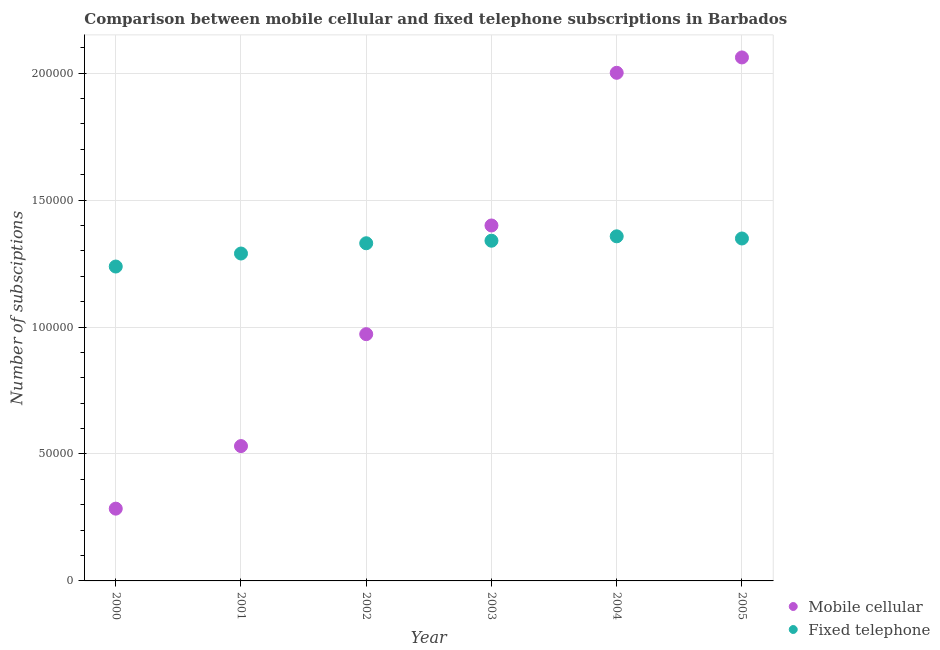Is the number of dotlines equal to the number of legend labels?
Offer a very short reply. Yes. What is the number of mobile cellular subscriptions in 2002?
Your answer should be very brief. 9.72e+04. Across all years, what is the maximum number of mobile cellular subscriptions?
Ensure brevity in your answer.  2.06e+05. Across all years, what is the minimum number of fixed telephone subscriptions?
Offer a very short reply. 1.24e+05. In which year was the number of fixed telephone subscriptions minimum?
Keep it short and to the point. 2000. What is the total number of mobile cellular subscriptions in the graph?
Keep it short and to the point. 7.25e+05. What is the difference between the number of mobile cellular subscriptions in 2004 and that in 2005?
Offer a very short reply. -6052. What is the difference between the number of mobile cellular subscriptions in 2001 and the number of fixed telephone subscriptions in 2000?
Offer a very short reply. -7.07e+04. What is the average number of fixed telephone subscriptions per year?
Offer a terse response. 1.32e+05. In the year 2001, what is the difference between the number of fixed telephone subscriptions and number of mobile cellular subscriptions?
Give a very brief answer. 7.58e+04. In how many years, is the number of fixed telephone subscriptions greater than 130000?
Your response must be concise. 4. What is the ratio of the number of fixed telephone subscriptions in 2002 to that in 2003?
Ensure brevity in your answer.  0.99. Is the number of fixed telephone subscriptions in 2000 less than that in 2001?
Make the answer very short. Yes. What is the difference between the highest and the second highest number of mobile cellular subscriptions?
Keep it short and to the point. 6052. What is the difference between the highest and the lowest number of mobile cellular subscriptions?
Give a very brief answer. 1.78e+05. In how many years, is the number of mobile cellular subscriptions greater than the average number of mobile cellular subscriptions taken over all years?
Your answer should be compact. 3. Does the number of mobile cellular subscriptions monotonically increase over the years?
Offer a terse response. Yes. Is the number of mobile cellular subscriptions strictly greater than the number of fixed telephone subscriptions over the years?
Make the answer very short. No. How many dotlines are there?
Your response must be concise. 2. How many years are there in the graph?
Give a very brief answer. 6. Does the graph contain grids?
Your response must be concise. Yes. How many legend labels are there?
Provide a succinct answer. 2. What is the title of the graph?
Your response must be concise. Comparison between mobile cellular and fixed telephone subscriptions in Barbados. Does "Male labor force" appear as one of the legend labels in the graph?
Your response must be concise. No. What is the label or title of the Y-axis?
Your response must be concise. Number of subsciptions. What is the Number of subsciptions in Mobile cellular in 2000?
Offer a very short reply. 2.85e+04. What is the Number of subsciptions in Fixed telephone in 2000?
Your answer should be compact. 1.24e+05. What is the Number of subsciptions in Mobile cellular in 2001?
Provide a short and direct response. 5.31e+04. What is the Number of subsciptions in Fixed telephone in 2001?
Offer a very short reply. 1.29e+05. What is the Number of subsciptions in Mobile cellular in 2002?
Ensure brevity in your answer.  9.72e+04. What is the Number of subsciptions in Fixed telephone in 2002?
Provide a succinct answer. 1.33e+05. What is the Number of subsciptions in Fixed telephone in 2003?
Your response must be concise. 1.34e+05. What is the Number of subsciptions of Mobile cellular in 2004?
Your response must be concise. 2.00e+05. What is the Number of subsciptions in Fixed telephone in 2004?
Offer a terse response. 1.36e+05. What is the Number of subsciptions in Mobile cellular in 2005?
Your answer should be compact. 2.06e+05. What is the Number of subsciptions in Fixed telephone in 2005?
Ensure brevity in your answer.  1.35e+05. Across all years, what is the maximum Number of subsciptions in Mobile cellular?
Give a very brief answer. 2.06e+05. Across all years, what is the maximum Number of subsciptions in Fixed telephone?
Provide a succinct answer. 1.36e+05. Across all years, what is the minimum Number of subsciptions in Mobile cellular?
Your answer should be compact. 2.85e+04. Across all years, what is the minimum Number of subsciptions of Fixed telephone?
Offer a terse response. 1.24e+05. What is the total Number of subsciptions of Mobile cellular in the graph?
Offer a very short reply. 7.25e+05. What is the total Number of subsciptions of Fixed telephone in the graph?
Ensure brevity in your answer.  7.90e+05. What is the difference between the Number of subsciptions of Mobile cellular in 2000 and that in 2001?
Your response must be concise. -2.46e+04. What is the difference between the Number of subsciptions of Fixed telephone in 2000 and that in 2001?
Ensure brevity in your answer.  -5124. What is the difference between the Number of subsciptions of Mobile cellular in 2000 and that in 2002?
Offer a very short reply. -6.87e+04. What is the difference between the Number of subsciptions of Fixed telephone in 2000 and that in 2002?
Provide a succinct answer. -9168. What is the difference between the Number of subsciptions in Mobile cellular in 2000 and that in 2003?
Offer a terse response. -1.12e+05. What is the difference between the Number of subsciptions of Fixed telephone in 2000 and that in 2003?
Your response must be concise. -1.02e+04. What is the difference between the Number of subsciptions of Mobile cellular in 2000 and that in 2004?
Give a very brief answer. -1.72e+05. What is the difference between the Number of subsciptions of Fixed telephone in 2000 and that in 2004?
Your answer should be compact. -1.19e+04. What is the difference between the Number of subsciptions in Mobile cellular in 2000 and that in 2005?
Your answer should be compact. -1.78e+05. What is the difference between the Number of subsciptions of Fixed telephone in 2000 and that in 2005?
Give a very brief answer. -1.10e+04. What is the difference between the Number of subsciptions of Mobile cellular in 2001 and that in 2002?
Your response must be concise. -4.41e+04. What is the difference between the Number of subsciptions of Fixed telephone in 2001 and that in 2002?
Offer a very short reply. -4044. What is the difference between the Number of subsciptions of Mobile cellular in 2001 and that in 2003?
Offer a very short reply. -8.69e+04. What is the difference between the Number of subsciptions of Fixed telephone in 2001 and that in 2003?
Offer a very short reply. -5044. What is the difference between the Number of subsciptions of Mobile cellular in 2001 and that in 2004?
Offer a very short reply. -1.47e+05. What is the difference between the Number of subsciptions of Fixed telephone in 2001 and that in 2004?
Give a very brief answer. -6776. What is the difference between the Number of subsciptions in Mobile cellular in 2001 and that in 2005?
Your answer should be compact. -1.53e+05. What is the difference between the Number of subsciptions in Fixed telephone in 2001 and that in 2005?
Your answer should be compact. -5922. What is the difference between the Number of subsciptions in Mobile cellular in 2002 and that in 2003?
Your answer should be compact. -4.28e+04. What is the difference between the Number of subsciptions in Fixed telephone in 2002 and that in 2003?
Keep it short and to the point. -1000. What is the difference between the Number of subsciptions of Mobile cellular in 2002 and that in 2004?
Provide a succinct answer. -1.03e+05. What is the difference between the Number of subsciptions in Fixed telephone in 2002 and that in 2004?
Ensure brevity in your answer.  -2732. What is the difference between the Number of subsciptions in Mobile cellular in 2002 and that in 2005?
Your answer should be very brief. -1.09e+05. What is the difference between the Number of subsciptions in Fixed telephone in 2002 and that in 2005?
Offer a very short reply. -1878. What is the difference between the Number of subsciptions in Mobile cellular in 2003 and that in 2004?
Your answer should be very brief. -6.01e+04. What is the difference between the Number of subsciptions of Fixed telephone in 2003 and that in 2004?
Your response must be concise. -1732. What is the difference between the Number of subsciptions in Mobile cellular in 2003 and that in 2005?
Keep it short and to the point. -6.62e+04. What is the difference between the Number of subsciptions in Fixed telephone in 2003 and that in 2005?
Ensure brevity in your answer.  -878. What is the difference between the Number of subsciptions in Mobile cellular in 2004 and that in 2005?
Your answer should be very brief. -6052. What is the difference between the Number of subsciptions of Fixed telephone in 2004 and that in 2005?
Provide a short and direct response. 854. What is the difference between the Number of subsciptions in Mobile cellular in 2000 and the Number of subsciptions in Fixed telephone in 2001?
Your answer should be very brief. -1.00e+05. What is the difference between the Number of subsciptions in Mobile cellular in 2000 and the Number of subsciptions in Fixed telephone in 2002?
Provide a short and direct response. -1.05e+05. What is the difference between the Number of subsciptions in Mobile cellular in 2000 and the Number of subsciptions in Fixed telephone in 2003?
Your response must be concise. -1.06e+05. What is the difference between the Number of subsciptions of Mobile cellular in 2000 and the Number of subsciptions of Fixed telephone in 2004?
Provide a succinct answer. -1.07e+05. What is the difference between the Number of subsciptions of Mobile cellular in 2000 and the Number of subsciptions of Fixed telephone in 2005?
Your response must be concise. -1.06e+05. What is the difference between the Number of subsciptions of Mobile cellular in 2001 and the Number of subsciptions of Fixed telephone in 2002?
Your answer should be very brief. -7.99e+04. What is the difference between the Number of subsciptions in Mobile cellular in 2001 and the Number of subsciptions in Fixed telephone in 2003?
Offer a terse response. -8.09e+04. What is the difference between the Number of subsciptions of Mobile cellular in 2001 and the Number of subsciptions of Fixed telephone in 2004?
Your answer should be very brief. -8.26e+04. What is the difference between the Number of subsciptions of Mobile cellular in 2001 and the Number of subsciptions of Fixed telephone in 2005?
Keep it short and to the point. -8.18e+04. What is the difference between the Number of subsciptions of Mobile cellular in 2002 and the Number of subsciptions of Fixed telephone in 2003?
Your response must be concise. -3.68e+04. What is the difference between the Number of subsciptions in Mobile cellular in 2002 and the Number of subsciptions in Fixed telephone in 2004?
Offer a very short reply. -3.85e+04. What is the difference between the Number of subsciptions in Mobile cellular in 2002 and the Number of subsciptions in Fixed telephone in 2005?
Your answer should be compact. -3.77e+04. What is the difference between the Number of subsciptions of Mobile cellular in 2003 and the Number of subsciptions of Fixed telephone in 2004?
Provide a succinct answer. 4268. What is the difference between the Number of subsciptions of Mobile cellular in 2003 and the Number of subsciptions of Fixed telephone in 2005?
Give a very brief answer. 5122. What is the difference between the Number of subsciptions of Mobile cellular in 2004 and the Number of subsciptions of Fixed telephone in 2005?
Offer a terse response. 6.53e+04. What is the average Number of subsciptions in Mobile cellular per year?
Keep it short and to the point. 1.21e+05. What is the average Number of subsciptions of Fixed telephone per year?
Make the answer very short. 1.32e+05. In the year 2000, what is the difference between the Number of subsciptions in Mobile cellular and Number of subsciptions in Fixed telephone?
Keep it short and to the point. -9.54e+04. In the year 2001, what is the difference between the Number of subsciptions in Mobile cellular and Number of subsciptions in Fixed telephone?
Your answer should be compact. -7.58e+04. In the year 2002, what is the difference between the Number of subsciptions in Mobile cellular and Number of subsciptions in Fixed telephone?
Provide a succinct answer. -3.58e+04. In the year 2003, what is the difference between the Number of subsciptions of Mobile cellular and Number of subsciptions of Fixed telephone?
Keep it short and to the point. 6000. In the year 2004, what is the difference between the Number of subsciptions in Mobile cellular and Number of subsciptions in Fixed telephone?
Your answer should be compact. 6.44e+04. In the year 2005, what is the difference between the Number of subsciptions of Mobile cellular and Number of subsciptions of Fixed telephone?
Provide a succinct answer. 7.13e+04. What is the ratio of the Number of subsciptions of Mobile cellular in 2000 to that in 2001?
Your answer should be compact. 0.54. What is the ratio of the Number of subsciptions of Fixed telephone in 2000 to that in 2001?
Ensure brevity in your answer.  0.96. What is the ratio of the Number of subsciptions in Mobile cellular in 2000 to that in 2002?
Ensure brevity in your answer.  0.29. What is the ratio of the Number of subsciptions in Fixed telephone in 2000 to that in 2002?
Offer a terse response. 0.93. What is the ratio of the Number of subsciptions in Mobile cellular in 2000 to that in 2003?
Ensure brevity in your answer.  0.2. What is the ratio of the Number of subsciptions in Fixed telephone in 2000 to that in 2003?
Provide a succinct answer. 0.92. What is the ratio of the Number of subsciptions in Mobile cellular in 2000 to that in 2004?
Your answer should be compact. 0.14. What is the ratio of the Number of subsciptions of Fixed telephone in 2000 to that in 2004?
Ensure brevity in your answer.  0.91. What is the ratio of the Number of subsciptions in Mobile cellular in 2000 to that in 2005?
Offer a very short reply. 0.14. What is the ratio of the Number of subsciptions in Fixed telephone in 2000 to that in 2005?
Provide a short and direct response. 0.92. What is the ratio of the Number of subsciptions of Mobile cellular in 2001 to that in 2002?
Provide a succinct answer. 0.55. What is the ratio of the Number of subsciptions in Fixed telephone in 2001 to that in 2002?
Offer a very short reply. 0.97. What is the ratio of the Number of subsciptions in Mobile cellular in 2001 to that in 2003?
Your answer should be very brief. 0.38. What is the ratio of the Number of subsciptions in Fixed telephone in 2001 to that in 2003?
Provide a succinct answer. 0.96. What is the ratio of the Number of subsciptions of Mobile cellular in 2001 to that in 2004?
Ensure brevity in your answer.  0.27. What is the ratio of the Number of subsciptions in Fixed telephone in 2001 to that in 2004?
Your answer should be compact. 0.95. What is the ratio of the Number of subsciptions of Mobile cellular in 2001 to that in 2005?
Give a very brief answer. 0.26. What is the ratio of the Number of subsciptions in Fixed telephone in 2001 to that in 2005?
Your answer should be compact. 0.96. What is the ratio of the Number of subsciptions of Mobile cellular in 2002 to that in 2003?
Make the answer very short. 0.69. What is the ratio of the Number of subsciptions of Fixed telephone in 2002 to that in 2003?
Offer a terse response. 0.99. What is the ratio of the Number of subsciptions of Mobile cellular in 2002 to that in 2004?
Provide a short and direct response. 0.49. What is the ratio of the Number of subsciptions in Fixed telephone in 2002 to that in 2004?
Ensure brevity in your answer.  0.98. What is the ratio of the Number of subsciptions of Mobile cellular in 2002 to that in 2005?
Offer a terse response. 0.47. What is the ratio of the Number of subsciptions in Fixed telephone in 2002 to that in 2005?
Give a very brief answer. 0.99. What is the ratio of the Number of subsciptions in Mobile cellular in 2003 to that in 2004?
Offer a very short reply. 0.7. What is the ratio of the Number of subsciptions in Fixed telephone in 2003 to that in 2004?
Give a very brief answer. 0.99. What is the ratio of the Number of subsciptions in Mobile cellular in 2003 to that in 2005?
Your response must be concise. 0.68. What is the ratio of the Number of subsciptions of Fixed telephone in 2003 to that in 2005?
Your response must be concise. 0.99. What is the ratio of the Number of subsciptions of Mobile cellular in 2004 to that in 2005?
Your answer should be compact. 0.97. What is the difference between the highest and the second highest Number of subsciptions of Mobile cellular?
Offer a terse response. 6052. What is the difference between the highest and the second highest Number of subsciptions of Fixed telephone?
Give a very brief answer. 854. What is the difference between the highest and the lowest Number of subsciptions of Mobile cellular?
Keep it short and to the point. 1.78e+05. What is the difference between the highest and the lowest Number of subsciptions of Fixed telephone?
Make the answer very short. 1.19e+04. 